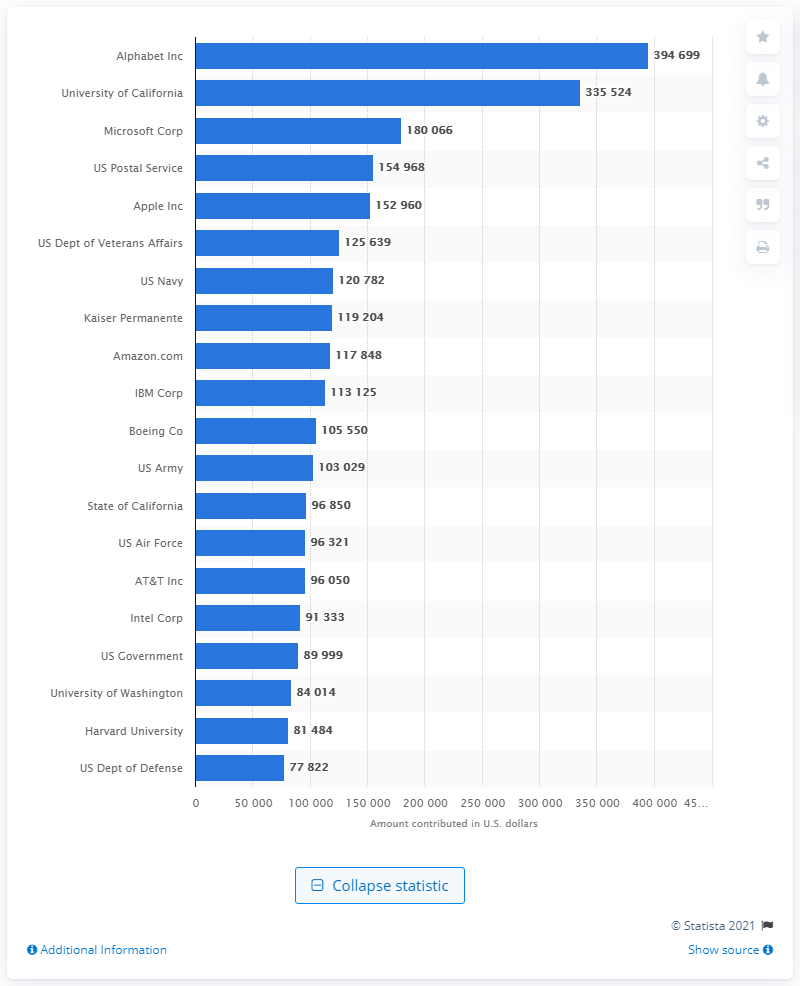Point out several critical features in this image. Alphabet Inc. donated 394,699 U.S. dollars to Bernie Sanders' campaign. 